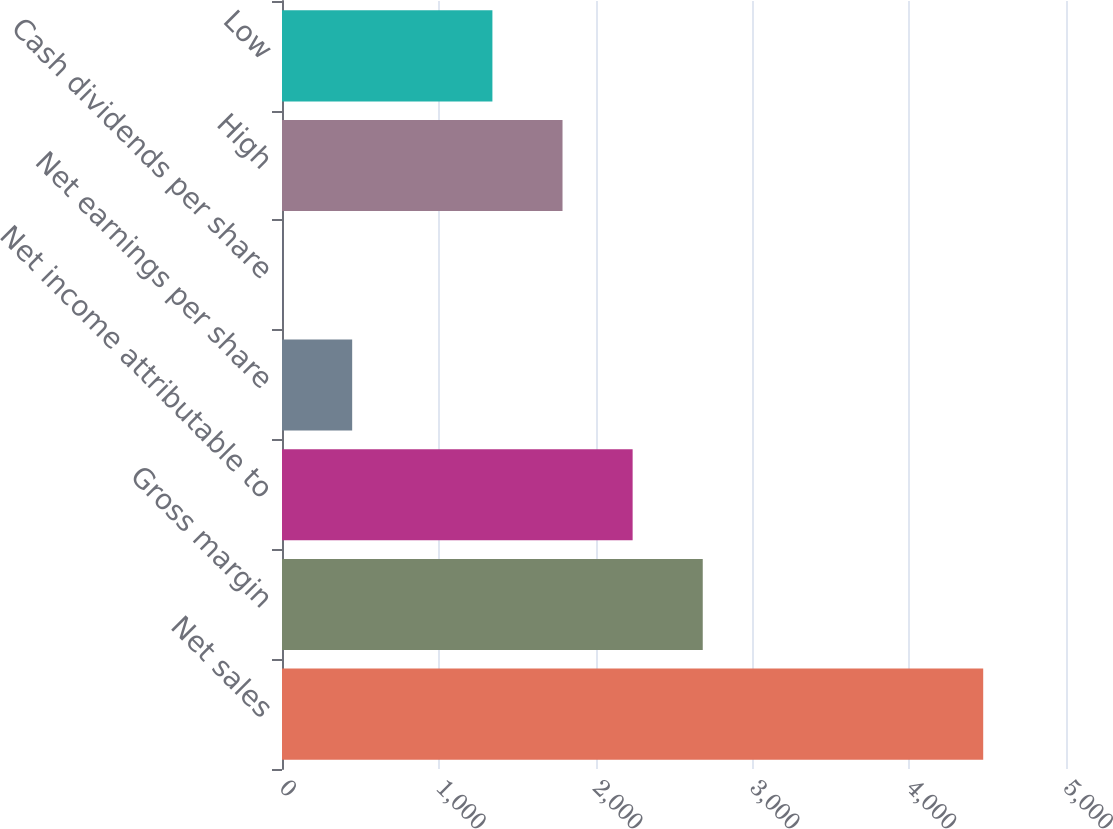<chart> <loc_0><loc_0><loc_500><loc_500><bar_chart><fcel>Net sales<fcel>Gross margin<fcel>Net income attributable to<fcel>Net earnings per share<fcel>Cash dividends per share<fcel>High<fcel>Low<nl><fcel>4472<fcel>2683.36<fcel>2236.2<fcel>447.56<fcel>0.4<fcel>1789.04<fcel>1341.88<nl></chart> 